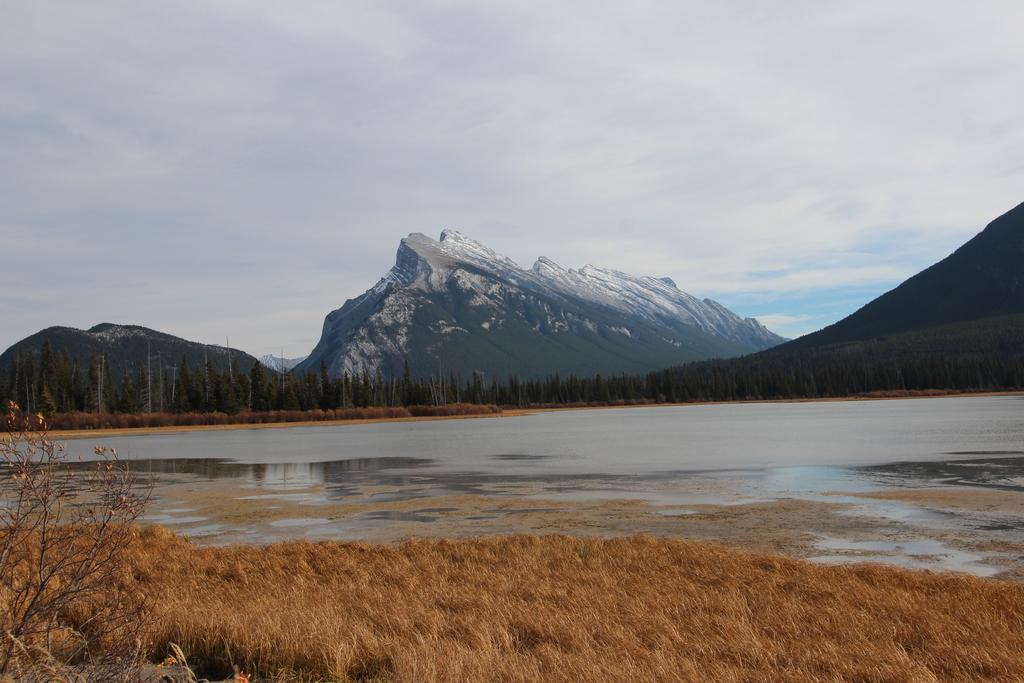Describe this image in one or two sentences. This is an outside view. At the bottom there is dry grass. In the middle of the image, I can see the water. In the background there are many trees and mountains. At the top of the image I can see the sky and clouds. 